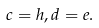Convert formula to latex. <formula><loc_0><loc_0><loc_500><loc_500>c = h , d = e .</formula> 